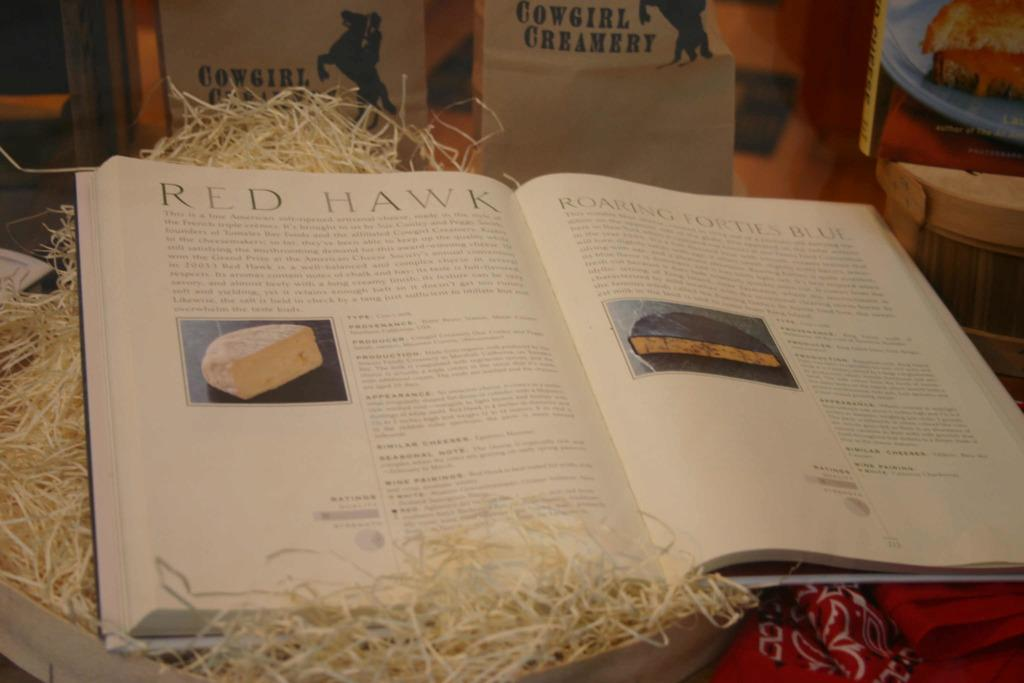<image>
Share a concise interpretation of the image provided. A book is opened to a page titled Red Hawk. 